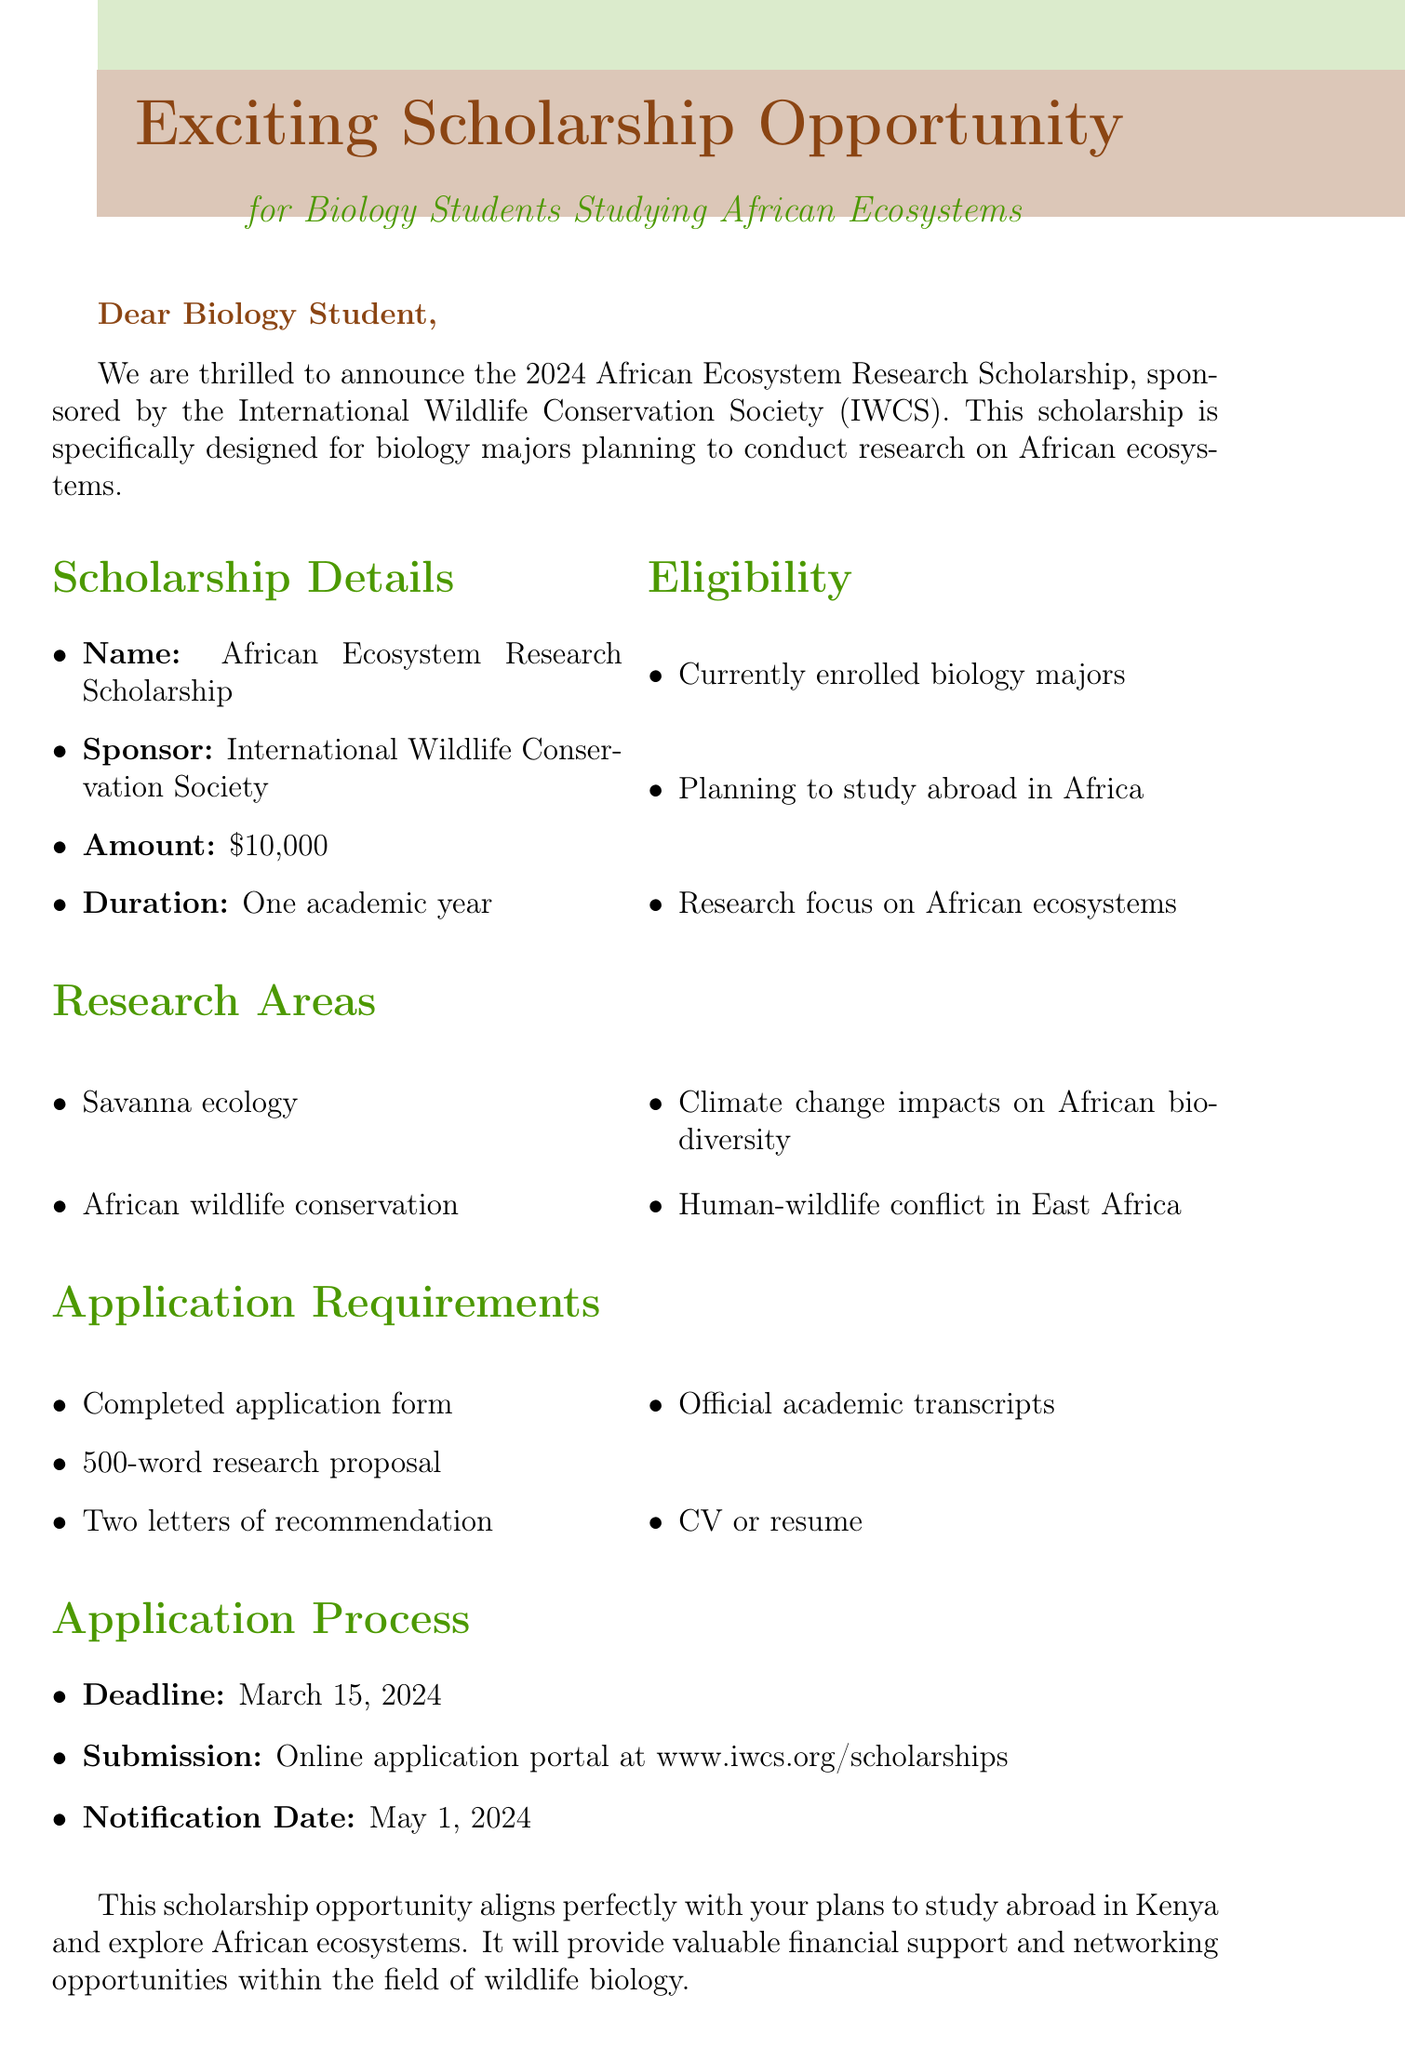What is the name of the scholarship? The scholarship is called the African Ecosystem Research Scholarship.
Answer: African Ecosystem Research Scholarship Who is the sponsor of the scholarship? The scholarship is sponsored by the International Wildlife Conservation Society.
Answer: International Wildlife Conservation Society What is the scholarship amount? The amount of the scholarship is stated as $10,000.
Answer: $10,000 What is the application deadline? The deadline for submitting the application is March 15, 2024.
Answer: March 15, 2024 What must the research proposal be limited to? The research proposal must be 500 words long.
Answer: 500-word What type of students are eligible for the scholarship? Eligibility includes currently enrolled biology majors.
Answer: Currently enrolled biology majors What will applicants receive notification about and when? Applicants will receive notification of the scholarship decision on May 1, 2024.
Answer: May 1, 2024 Who should applicants contact for more information? The contact person for more information is Dr. Sarah Ndovu.
Answer: Dr. Sarah Ndovu What research areas are highlighted for this scholarship? Research areas include savanna ecology, African wildlife conservation, and more.
Answer: Savanna ecology, African wildlife conservation What is the duration of the scholarship? The duration of the scholarship is one academic year.
Answer: One academic year 